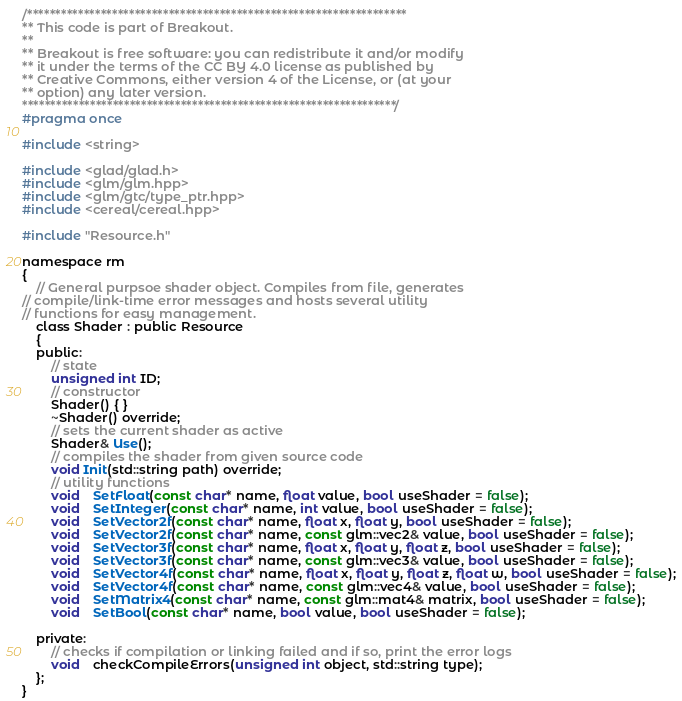Convert code to text. <code><loc_0><loc_0><loc_500><loc_500><_C_>/*******************************************************************
** This code is part of Breakout.
**
** Breakout is free software: you can redistribute it and/or modify
** it under the terms of the CC BY 4.0 license as published by
** Creative Commons, either version 4 of the License, or (at your
** option) any later version.
******************************************************************/
#pragma once

#include <string>

#include <glad/glad.h>
#include <glm/glm.hpp>
#include <glm/gtc/type_ptr.hpp>
#include <cereal/cereal.hpp>

#include "Resource.h"

namespace rm
{
    // General purpsoe shader object. Compiles from file, generates
// compile/link-time error messages and hosts several utility 
// functions for easy management.
    class Shader : public Resource
    {
    public:
        // state
        unsigned int ID;
        // constructor
        Shader() { }
        ~Shader() override;
        // sets the current shader as active
        Shader& Use();
        // compiles the shader from given source code
        void Init(std::string path) override;
        // utility functions
        void    SetFloat(const char* name, float value, bool useShader = false);
        void    SetInteger(const char* name, int value, bool useShader = false);
        void    SetVector2f(const char* name, float x, float y, bool useShader = false);
        void    SetVector2f(const char* name, const glm::vec2& value, bool useShader = false);
        void    SetVector3f(const char* name, float x, float y, float z, bool useShader = false);
        void    SetVector3f(const char* name, const glm::vec3& value, bool useShader = false);
        void    SetVector4f(const char* name, float x, float y, float z, float w, bool useShader = false);
        void    SetVector4f(const char* name, const glm::vec4& value, bool useShader = false);
        void    SetMatrix4(const char* name, const glm::mat4& matrix, bool useShader = false);
        void    SetBool(const char* name, bool value, bool useShader = false);

    private:
        // checks if compilation or linking failed and if so, print the error logs
        void    checkCompileErrors(unsigned int object, std::string type);
    };
}</code> 